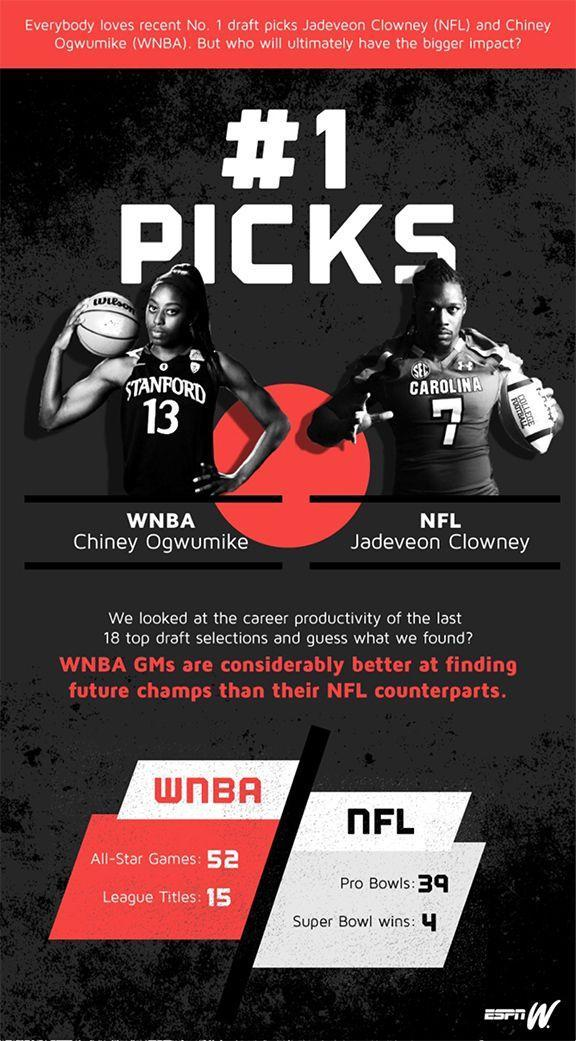How many super bowl wins were made by Jadeveon Clowney in NFL games?
Answer the question with a short phrase. 4 How many league titles have Chiney Ogwumike won? 15 What is the jersey number of Jadeveon Clowney? 7 What is the jersey number of Chiney Ogwumike? 13 